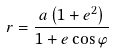Convert formula to latex. <formula><loc_0><loc_0><loc_500><loc_500>r = \frac { a \left ( 1 + e ^ { 2 } \right ) } { 1 + e \cos \varphi }</formula> 